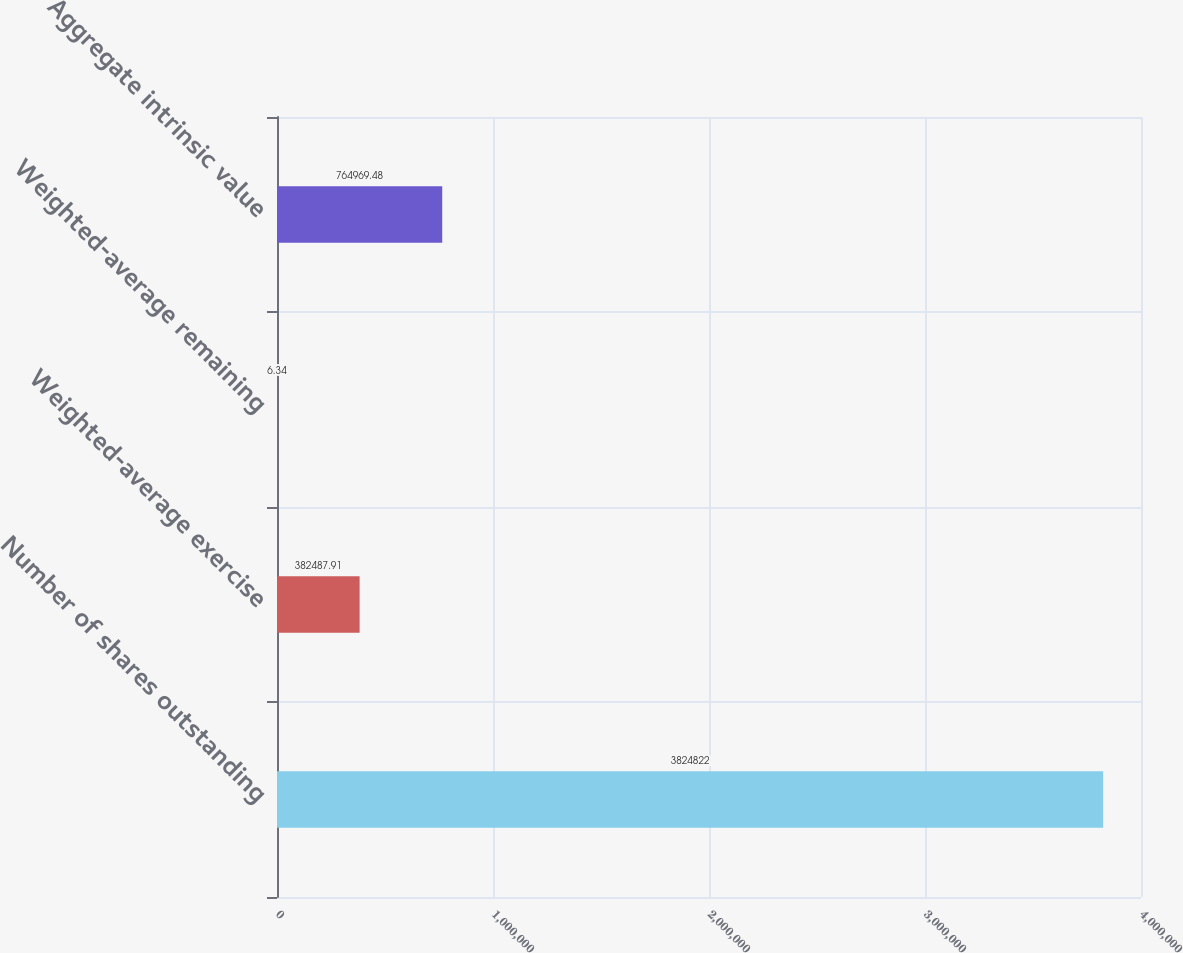Convert chart to OTSL. <chart><loc_0><loc_0><loc_500><loc_500><bar_chart><fcel>Number of shares outstanding<fcel>Weighted-average exercise<fcel>Weighted-average remaining<fcel>Aggregate intrinsic value<nl><fcel>3.82482e+06<fcel>382488<fcel>6.34<fcel>764969<nl></chart> 